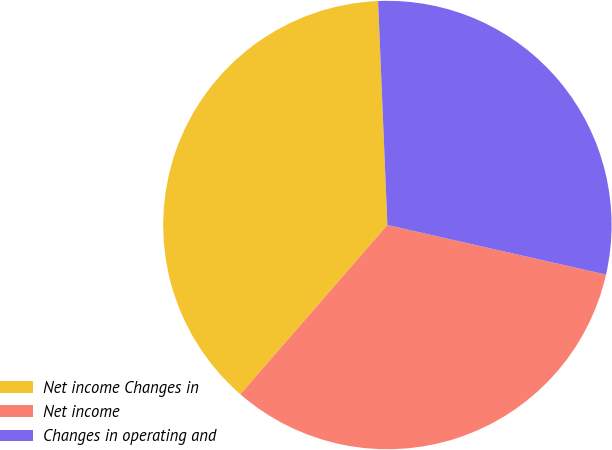Convert chart to OTSL. <chart><loc_0><loc_0><loc_500><loc_500><pie_chart><fcel>Net income Changes in<fcel>Net income<fcel>Changes in operating and<nl><fcel>37.96%<fcel>32.84%<fcel>29.21%<nl></chart> 